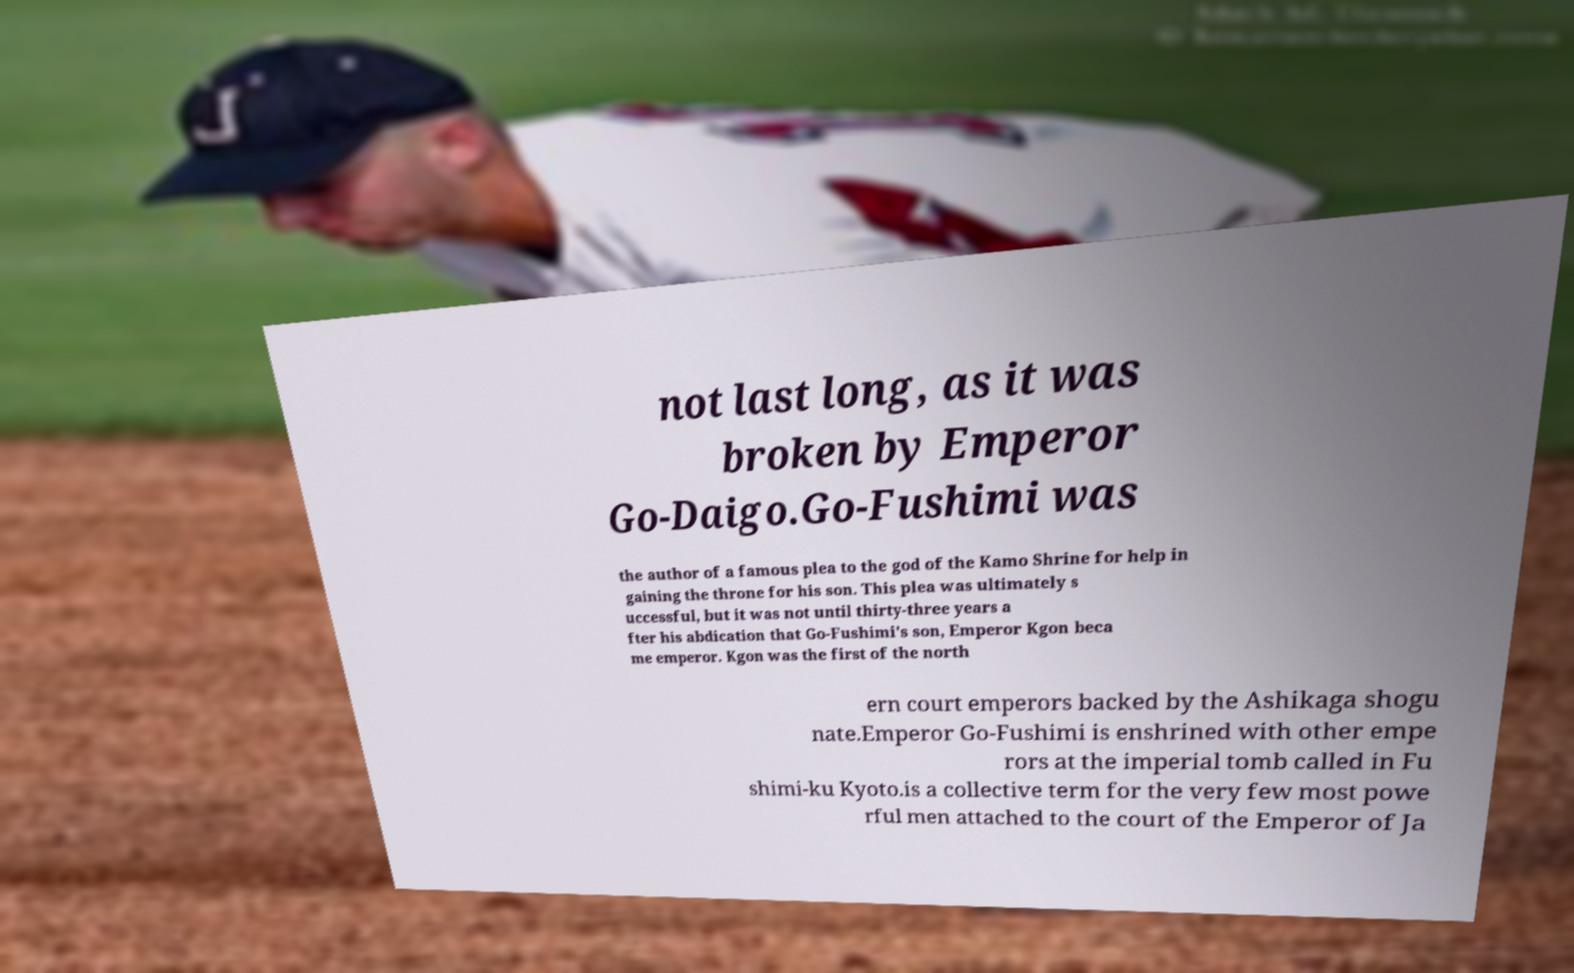For documentation purposes, I need the text within this image transcribed. Could you provide that? not last long, as it was broken by Emperor Go-Daigo.Go-Fushimi was the author of a famous plea to the god of the Kamo Shrine for help in gaining the throne for his son. This plea was ultimately s uccessful, but it was not until thirty-three years a fter his abdication that Go-Fushimi's son, Emperor Kgon beca me emperor. Kgon was the first of the north ern court emperors backed by the Ashikaga shogu nate.Emperor Go-Fushimi is enshrined with other empe rors at the imperial tomb called in Fu shimi-ku Kyoto.is a collective term for the very few most powe rful men attached to the court of the Emperor of Ja 